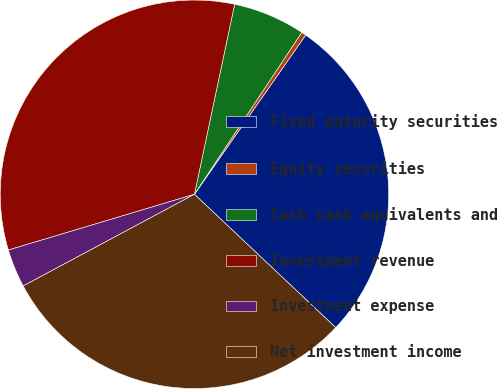Convert chart to OTSL. <chart><loc_0><loc_0><loc_500><loc_500><pie_chart><fcel>Fixed maturity securities<fcel>Equity securities<fcel>Cash cash equivalents and<fcel>Investment revenue<fcel>Investment expense<fcel>Net investment income<nl><fcel>27.33%<fcel>0.39%<fcel>6.0%<fcel>32.95%<fcel>3.19%<fcel>30.14%<nl></chart> 